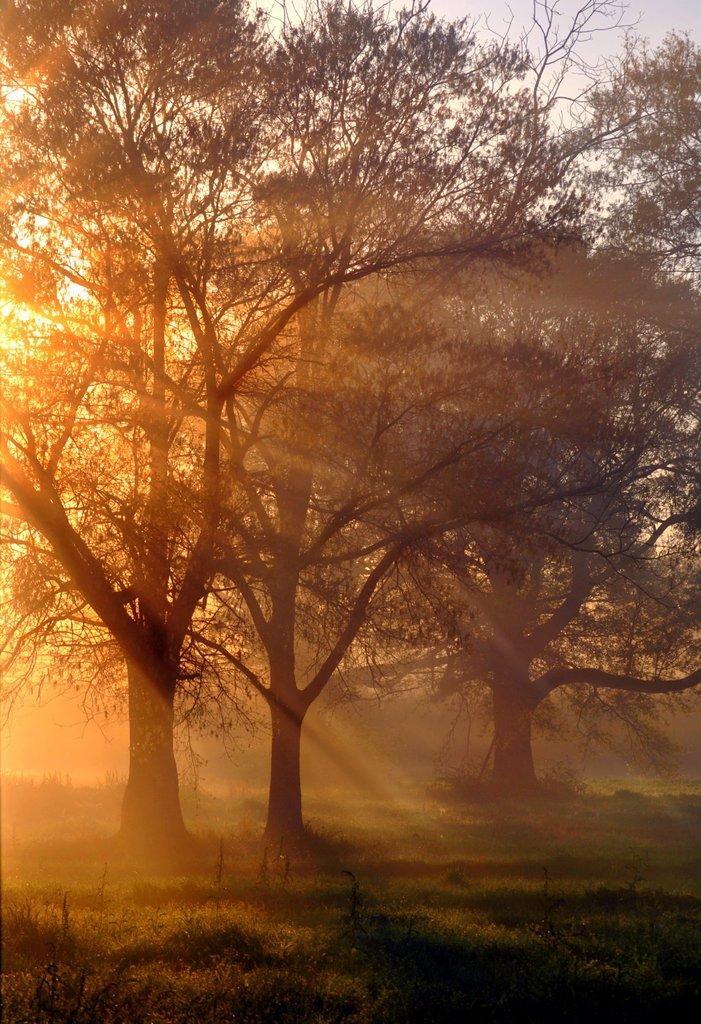Can you describe this image briefly? In this image I can see the grass and many trees. In the background I can see the sky. 